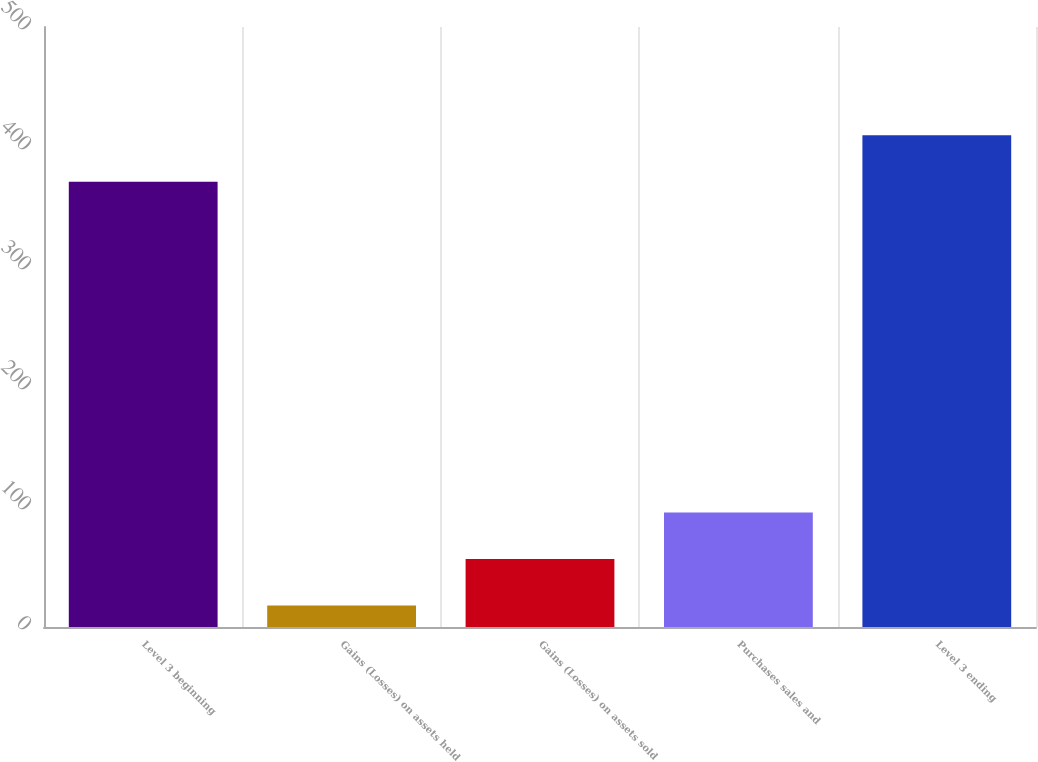Convert chart to OTSL. <chart><loc_0><loc_0><loc_500><loc_500><bar_chart><fcel>Level 3 beginning<fcel>Gains (Losses) on assets held<fcel>Gains (Losses) on assets sold<fcel>Purchases sales and<fcel>Level 3 ending<nl><fcel>371<fcel>18<fcel>56.7<fcel>95.4<fcel>409.7<nl></chart> 